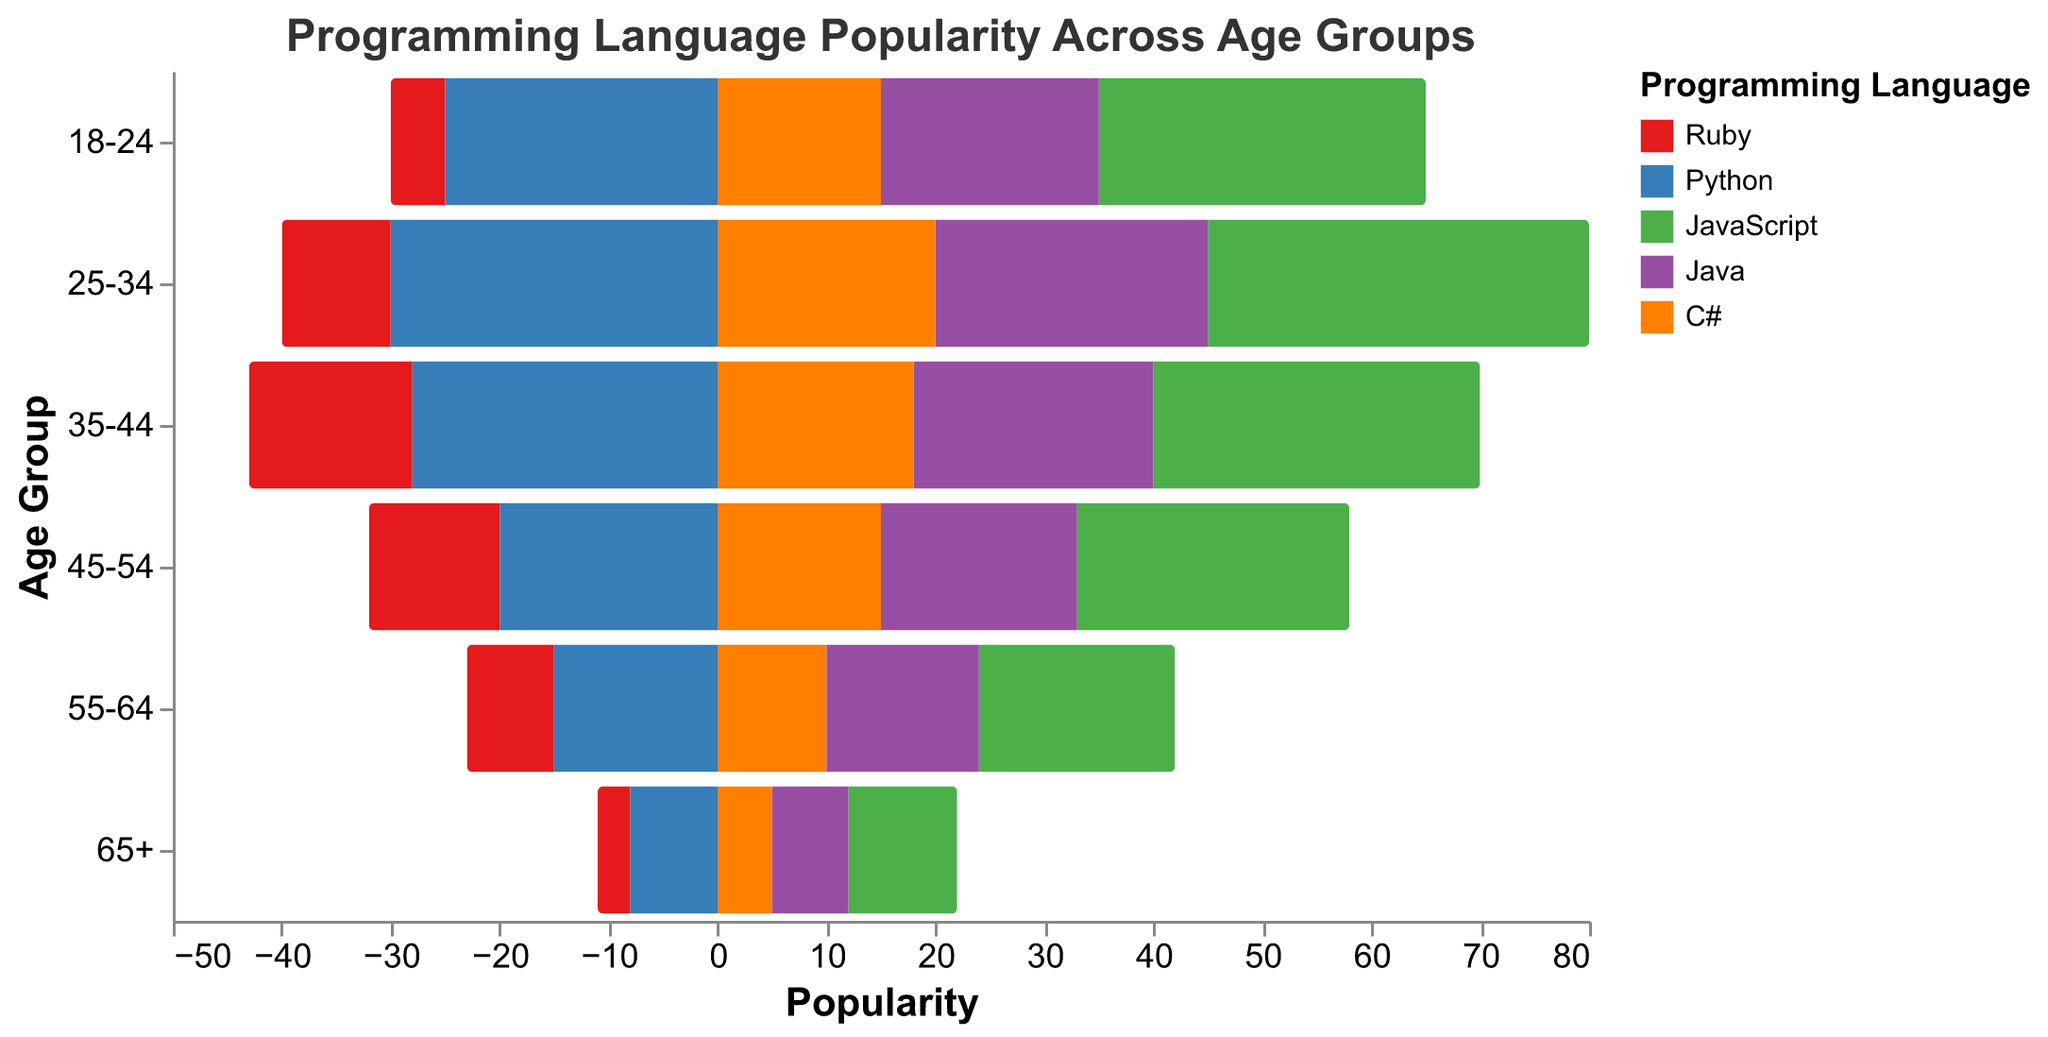Which age group shows the highest popularity for Python? By looking at the heights of the bars corresponding to Python's popularity in different age groups, we identify that the age group with the longest bar for Python is 25-34.
Answer: 25-34 Which programming language is the least popular in the 65+ age group? By comparing the bar lengths for all programming languages in the 65+ age group, Ruby has the shortest bar, indicating it has the least popularity.
Answer: Ruby How does the popularity of JavaScript change from the 18-24 age group to the 55-64 age group? We observe the heights of the JavaScript bars across different age groups and see that from 18-24 to 55-64, the bar length decreases from 30 to 18, showing that its popularity decreases.
Answer: Decreases What is the total popularity of Ruby in all age groups combined? To find this, add the values of Ruby across all age groups: 5 + 10 + 15 + 12 + 8 + 3 = 53.
Answer: 53 Is Python more popular than Java in the age group 45-54? Compare the heights of the bars for Python and Java in the 45-54 age group. Python has a higher value (20) compared to Java (18).
Answer: Yes Which age group has the lowest overall popularity for all programming languages combined? Sum the popularity values of all languages for each age group and identify the one with the lowest total: 
18-24: 95, 25-34: 120, 35-44: 113, 45-54: 90, 55-64: 65, 65+: 33. 
The age group 65+ has the lowest total (33).
Answer: 65+ Compare the popularity of C# in the 25-34 age group to its popularity in the 35-44 age group. The bars for C# show values of 20 in the 25-34 age group and 18 in the 35-44 age group, indicating a decrease.
Answer: Decreases What is the difference in popularity between Ruby and JavaScript in the 35-44 age group? Subtract the popularity of Ruby (15) from the popularity of JavaScript (30) in the 35-44 age group. The difference is 30 - 15 = 15.
Answer: 15 How does the popularity of C# in the 55-64 age group compare to Ruby in the same age group? Compare the bar lengths for Ruby (8) and C# (10) in the 55-64 age group. The bar for C# is longer, indicating higher popularity.
Answer: Higher Which age group shows an equal popularity for JavaScript and Python? By examining the heights of the bars for JavaScript and Python across all age groups, we see that both have a popularity of 30 in the 35-44 age group.
Answer: 35-44 